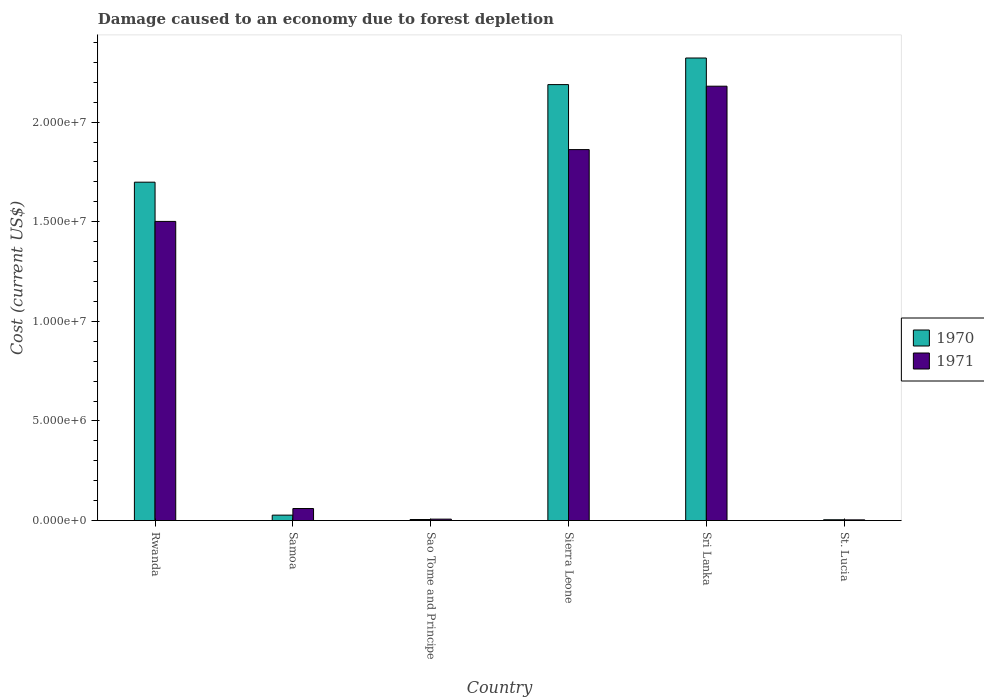How many groups of bars are there?
Ensure brevity in your answer.  6. Are the number of bars per tick equal to the number of legend labels?
Provide a short and direct response. Yes. Are the number of bars on each tick of the X-axis equal?
Your answer should be compact. Yes. How many bars are there on the 4th tick from the left?
Offer a terse response. 2. What is the label of the 2nd group of bars from the left?
Your answer should be compact. Samoa. What is the cost of damage caused due to forest depletion in 1970 in St. Lucia?
Provide a succinct answer. 4.11e+04. Across all countries, what is the maximum cost of damage caused due to forest depletion in 1971?
Provide a succinct answer. 2.18e+07. Across all countries, what is the minimum cost of damage caused due to forest depletion in 1970?
Give a very brief answer. 4.11e+04. In which country was the cost of damage caused due to forest depletion in 1970 maximum?
Offer a terse response. Sri Lanka. In which country was the cost of damage caused due to forest depletion in 1971 minimum?
Provide a short and direct response. St. Lucia. What is the total cost of damage caused due to forest depletion in 1970 in the graph?
Provide a short and direct response. 6.24e+07. What is the difference between the cost of damage caused due to forest depletion in 1970 in Samoa and that in St. Lucia?
Keep it short and to the point. 2.32e+05. What is the difference between the cost of damage caused due to forest depletion in 1970 in Sri Lanka and the cost of damage caused due to forest depletion in 1971 in St. Lucia?
Your response must be concise. 2.32e+07. What is the average cost of damage caused due to forest depletion in 1971 per country?
Give a very brief answer. 9.36e+06. What is the difference between the cost of damage caused due to forest depletion of/in 1971 and cost of damage caused due to forest depletion of/in 1970 in Sri Lanka?
Your answer should be compact. -1.42e+06. What is the ratio of the cost of damage caused due to forest depletion in 1970 in Sao Tome and Principe to that in St. Lucia?
Provide a succinct answer. 1.29. Is the difference between the cost of damage caused due to forest depletion in 1971 in Rwanda and Samoa greater than the difference between the cost of damage caused due to forest depletion in 1970 in Rwanda and Samoa?
Provide a short and direct response. No. What is the difference between the highest and the second highest cost of damage caused due to forest depletion in 1971?
Provide a short and direct response. -6.79e+06. What is the difference between the highest and the lowest cost of damage caused due to forest depletion in 1970?
Provide a short and direct response. 2.32e+07. In how many countries, is the cost of damage caused due to forest depletion in 1971 greater than the average cost of damage caused due to forest depletion in 1971 taken over all countries?
Your response must be concise. 3. What does the 1st bar from the left in Rwanda represents?
Provide a short and direct response. 1970. What does the 2nd bar from the right in Sri Lanka represents?
Offer a very short reply. 1970. How many bars are there?
Offer a terse response. 12. What is the difference between two consecutive major ticks on the Y-axis?
Provide a succinct answer. 5.00e+06. Are the values on the major ticks of Y-axis written in scientific E-notation?
Offer a very short reply. Yes. Does the graph contain any zero values?
Keep it short and to the point. No. Does the graph contain grids?
Make the answer very short. No. Where does the legend appear in the graph?
Keep it short and to the point. Center right. How many legend labels are there?
Your response must be concise. 2. What is the title of the graph?
Provide a succinct answer. Damage caused to an economy due to forest depletion. Does "2000" appear as one of the legend labels in the graph?
Provide a succinct answer. No. What is the label or title of the X-axis?
Your answer should be compact. Country. What is the label or title of the Y-axis?
Provide a succinct answer. Cost (current US$). What is the Cost (current US$) of 1970 in Rwanda?
Offer a terse response. 1.70e+07. What is the Cost (current US$) of 1971 in Rwanda?
Keep it short and to the point. 1.50e+07. What is the Cost (current US$) of 1970 in Samoa?
Give a very brief answer. 2.73e+05. What is the Cost (current US$) of 1971 in Samoa?
Provide a short and direct response. 6.05e+05. What is the Cost (current US$) of 1970 in Sao Tome and Principe?
Your answer should be compact. 5.31e+04. What is the Cost (current US$) in 1971 in Sao Tome and Principe?
Ensure brevity in your answer.  7.23e+04. What is the Cost (current US$) of 1970 in Sierra Leone?
Offer a terse response. 2.19e+07. What is the Cost (current US$) of 1971 in Sierra Leone?
Your response must be concise. 1.86e+07. What is the Cost (current US$) of 1970 in Sri Lanka?
Make the answer very short. 2.32e+07. What is the Cost (current US$) of 1971 in Sri Lanka?
Keep it short and to the point. 2.18e+07. What is the Cost (current US$) in 1970 in St. Lucia?
Your answer should be very brief. 4.11e+04. What is the Cost (current US$) in 1971 in St. Lucia?
Your response must be concise. 3.58e+04. Across all countries, what is the maximum Cost (current US$) in 1970?
Provide a short and direct response. 2.32e+07. Across all countries, what is the maximum Cost (current US$) of 1971?
Ensure brevity in your answer.  2.18e+07. Across all countries, what is the minimum Cost (current US$) of 1970?
Give a very brief answer. 4.11e+04. Across all countries, what is the minimum Cost (current US$) in 1971?
Your answer should be very brief. 3.58e+04. What is the total Cost (current US$) of 1970 in the graph?
Keep it short and to the point. 6.24e+07. What is the total Cost (current US$) of 1971 in the graph?
Provide a succinct answer. 5.61e+07. What is the difference between the Cost (current US$) of 1970 in Rwanda and that in Samoa?
Offer a very short reply. 1.67e+07. What is the difference between the Cost (current US$) in 1971 in Rwanda and that in Samoa?
Your answer should be compact. 1.44e+07. What is the difference between the Cost (current US$) in 1970 in Rwanda and that in Sao Tome and Principe?
Give a very brief answer. 1.69e+07. What is the difference between the Cost (current US$) in 1971 in Rwanda and that in Sao Tome and Principe?
Your answer should be very brief. 1.49e+07. What is the difference between the Cost (current US$) in 1970 in Rwanda and that in Sierra Leone?
Provide a succinct answer. -4.90e+06. What is the difference between the Cost (current US$) in 1971 in Rwanda and that in Sierra Leone?
Provide a short and direct response. -3.60e+06. What is the difference between the Cost (current US$) in 1970 in Rwanda and that in Sri Lanka?
Ensure brevity in your answer.  -6.23e+06. What is the difference between the Cost (current US$) of 1971 in Rwanda and that in Sri Lanka?
Offer a very short reply. -6.79e+06. What is the difference between the Cost (current US$) of 1970 in Rwanda and that in St. Lucia?
Keep it short and to the point. 1.69e+07. What is the difference between the Cost (current US$) of 1971 in Rwanda and that in St. Lucia?
Provide a short and direct response. 1.50e+07. What is the difference between the Cost (current US$) of 1970 in Samoa and that in Sao Tome and Principe?
Ensure brevity in your answer.  2.20e+05. What is the difference between the Cost (current US$) in 1971 in Samoa and that in Sao Tome and Principe?
Your response must be concise. 5.33e+05. What is the difference between the Cost (current US$) of 1970 in Samoa and that in Sierra Leone?
Your response must be concise. -2.16e+07. What is the difference between the Cost (current US$) of 1971 in Samoa and that in Sierra Leone?
Provide a succinct answer. -1.80e+07. What is the difference between the Cost (current US$) of 1970 in Samoa and that in Sri Lanka?
Your answer should be compact. -2.29e+07. What is the difference between the Cost (current US$) of 1971 in Samoa and that in Sri Lanka?
Your response must be concise. -2.12e+07. What is the difference between the Cost (current US$) in 1970 in Samoa and that in St. Lucia?
Provide a short and direct response. 2.32e+05. What is the difference between the Cost (current US$) of 1971 in Samoa and that in St. Lucia?
Provide a succinct answer. 5.69e+05. What is the difference between the Cost (current US$) of 1970 in Sao Tome and Principe and that in Sierra Leone?
Your answer should be compact. -2.18e+07. What is the difference between the Cost (current US$) of 1971 in Sao Tome and Principe and that in Sierra Leone?
Offer a very short reply. -1.85e+07. What is the difference between the Cost (current US$) in 1970 in Sao Tome and Principe and that in Sri Lanka?
Your answer should be compact. -2.32e+07. What is the difference between the Cost (current US$) in 1971 in Sao Tome and Principe and that in Sri Lanka?
Give a very brief answer. -2.17e+07. What is the difference between the Cost (current US$) in 1970 in Sao Tome and Principe and that in St. Lucia?
Make the answer very short. 1.20e+04. What is the difference between the Cost (current US$) of 1971 in Sao Tome and Principe and that in St. Lucia?
Your answer should be very brief. 3.65e+04. What is the difference between the Cost (current US$) of 1970 in Sierra Leone and that in Sri Lanka?
Provide a short and direct response. -1.34e+06. What is the difference between the Cost (current US$) of 1971 in Sierra Leone and that in Sri Lanka?
Ensure brevity in your answer.  -3.18e+06. What is the difference between the Cost (current US$) of 1970 in Sierra Leone and that in St. Lucia?
Provide a succinct answer. 2.18e+07. What is the difference between the Cost (current US$) in 1971 in Sierra Leone and that in St. Lucia?
Ensure brevity in your answer.  1.86e+07. What is the difference between the Cost (current US$) in 1970 in Sri Lanka and that in St. Lucia?
Offer a very short reply. 2.32e+07. What is the difference between the Cost (current US$) of 1971 in Sri Lanka and that in St. Lucia?
Provide a succinct answer. 2.18e+07. What is the difference between the Cost (current US$) of 1970 in Rwanda and the Cost (current US$) of 1971 in Samoa?
Your answer should be very brief. 1.64e+07. What is the difference between the Cost (current US$) in 1970 in Rwanda and the Cost (current US$) in 1971 in Sao Tome and Principe?
Provide a short and direct response. 1.69e+07. What is the difference between the Cost (current US$) of 1970 in Rwanda and the Cost (current US$) of 1971 in Sierra Leone?
Make the answer very short. -1.63e+06. What is the difference between the Cost (current US$) of 1970 in Rwanda and the Cost (current US$) of 1971 in Sri Lanka?
Your answer should be very brief. -4.82e+06. What is the difference between the Cost (current US$) of 1970 in Rwanda and the Cost (current US$) of 1971 in St. Lucia?
Your answer should be compact. 1.69e+07. What is the difference between the Cost (current US$) in 1970 in Samoa and the Cost (current US$) in 1971 in Sao Tome and Principe?
Provide a short and direct response. 2.01e+05. What is the difference between the Cost (current US$) in 1970 in Samoa and the Cost (current US$) in 1971 in Sierra Leone?
Give a very brief answer. -1.83e+07. What is the difference between the Cost (current US$) in 1970 in Samoa and the Cost (current US$) in 1971 in Sri Lanka?
Keep it short and to the point. -2.15e+07. What is the difference between the Cost (current US$) in 1970 in Samoa and the Cost (current US$) in 1971 in St. Lucia?
Provide a succinct answer. 2.37e+05. What is the difference between the Cost (current US$) of 1970 in Sao Tome and Principe and the Cost (current US$) of 1971 in Sierra Leone?
Your answer should be compact. -1.86e+07. What is the difference between the Cost (current US$) in 1970 in Sao Tome and Principe and the Cost (current US$) in 1971 in Sri Lanka?
Provide a short and direct response. -2.17e+07. What is the difference between the Cost (current US$) of 1970 in Sao Tome and Principe and the Cost (current US$) of 1971 in St. Lucia?
Offer a terse response. 1.73e+04. What is the difference between the Cost (current US$) of 1970 in Sierra Leone and the Cost (current US$) of 1971 in Sri Lanka?
Your answer should be compact. 8.01e+04. What is the difference between the Cost (current US$) in 1970 in Sierra Leone and the Cost (current US$) in 1971 in St. Lucia?
Offer a terse response. 2.18e+07. What is the difference between the Cost (current US$) in 1970 in Sri Lanka and the Cost (current US$) in 1971 in St. Lucia?
Your response must be concise. 2.32e+07. What is the average Cost (current US$) of 1970 per country?
Ensure brevity in your answer.  1.04e+07. What is the average Cost (current US$) of 1971 per country?
Ensure brevity in your answer.  9.36e+06. What is the difference between the Cost (current US$) of 1970 and Cost (current US$) of 1971 in Rwanda?
Offer a very short reply. 1.97e+06. What is the difference between the Cost (current US$) of 1970 and Cost (current US$) of 1971 in Samoa?
Make the answer very short. -3.32e+05. What is the difference between the Cost (current US$) of 1970 and Cost (current US$) of 1971 in Sao Tome and Principe?
Provide a short and direct response. -1.92e+04. What is the difference between the Cost (current US$) in 1970 and Cost (current US$) in 1971 in Sierra Leone?
Offer a very short reply. 3.26e+06. What is the difference between the Cost (current US$) of 1970 and Cost (current US$) of 1971 in Sri Lanka?
Offer a very short reply. 1.42e+06. What is the difference between the Cost (current US$) of 1970 and Cost (current US$) of 1971 in St. Lucia?
Your answer should be compact. 5318.94. What is the ratio of the Cost (current US$) of 1970 in Rwanda to that in Samoa?
Offer a terse response. 62.21. What is the ratio of the Cost (current US$) in 1971 in Rwanda to that in Samoa?
Your answer should be compact. 24.81. What is the ratio of the Cost (current US$) in 1970 in Rwanda to that in Sao Tome and Principe?
Keep it short and to the point. 320.03. What is the ratio of the Cost (current US$) in 1971 in Rwanda to that in Sao Tome and Principe?
Your response must be concise. 207.63. What is the ratio of the Cost (current US$) of 1970 in Rwanda to that in Sierra Leone?
Provide a succinct answer. 0.78. What is the ratio of the Cost (current US$) in 1971 in Rwanda to that in Sierra Leone?
Provide a succinct answer. 0.81. What is the ratio of the Cost (current US$) in 1970 in Rwanda to that in Sri Lanka?
Ensure brevity in your answer.  0.73. What is the ratio of the Cost (current US$) in 1971 in Rwanda to that in Sri Lanka?
Provide a succinct answer. 0.69. What is the ratio of the Cost (current US$) of 1970 in Rwanda to that in St. Lucia?
Your answer should be very brief. 413.15. What is the ratio of the Cost (current US$) of 1971 in Rwanda to that in St. Lucia?
Ensure brevity in your answer.  419.52. What is the ratio of the Cost (current US$) of 1970 in Samoa to that in Sao Tome and Principe?
Keep it short and to the point. 5.14. What is the ratio of the Cost (current US$) of 1971 in Samoa to that in Sao Tome and Principe?
Make the answer very short. 8.37. What is the ratio of the Cost (current US$) of 1970 in Samoa to that in Sierra Leone?
Provide a succinct answer. 0.01. What is the ratio of the Cost (current US$) in 1971 in Samoa to that in Sierra Leone?
Make the answer very short. 0.03. What is the ratio of the Cost (current US$) in 1970 in Samoa to that in Sri Lanka?
Offer a terse response. 0.01. What is the ratio of the Cost (current US$) of 1971 in Samoa to that in Sri Lanka?
Make the answer very short. 0.03. What is the ratio of the Cost (current US$) of 1970 in Samoa to that in St. Lucia?
Your answer should be very brief. 6.64. What is the ratio of the Cost (current US$) of 1971 in Samoa to that in St. Lucia?
Offer a terse response. 16.91. What is the ratio of the Cost (current US$) of 1970 in Sao Tome and Principe to that in Sierra Leone?
Your answer should be compact. 0. What is the ratio of the Cost (current US$) in 1971 in Sao Tome and Principe to that in Sierra Leone?
Your answer should be very brief. 0. What is the ratio of the Cost (current US$) in 1970 in Sao Tome and Principe to that in Sri Lanka?
Your response must be concise. 0. What is the ratio of the Cost (current US$) of 1971 in Sao Tome and Principe to that in Sri Lanka?
Give a very brief answer. 0. What is the ratio of the Cost (current US$) of 1970 in Sao Tome and Principe to that in St. Lucia?
Provide a short and direct response. 1.29. What is the ratio of the Cost (current US$) in 1971 in Sao Tome and Principe to that in St. Lucia?
Provide a short and direct response. 2.02. What is the ratio of the Cost (current US$) of 1970 in Sierra Leone to that in Sri Lanka?
Provide a short and direct response. 0.94. What is the ratio of the Cost (current US$) of 1971 in Sierra Leone to that in Sri Lanka?
Your answer should be very brief. 0.85. What is the ratio of the Cost (current US$) in 1970 in Sierra Leone to that in St. Lucia?
Your response must be concise. 532.27. What is the ratio of the Cost (current US$) in 1971 in Sierra Leone to that in St. Lucia?
Keep it short and to the point. 520.23. What is the ratio of the Cost (current US$) of 1970 in Sri Lanka to that in St. Lucia?
Offer a terse response. 564.74. What is the ratio of the Cost (current US$) of 1971 in Sri Lanka to that in St. Lucia?
Provide a short and direct response. 609.13. What is the difference between the highest and the second highest Cost (current US$) in 1970?
Your answer should be compact. 1.34e+06. What is the difference between the highest and the second highest Cost (current US$) in 1971?
Provide a succinct answer. 3.18e+06. What is the difference between the highest and the lowest Cost (current US$) in 1970?
Make the answer very short. 2.32e+07. What is the difference between the highest and the lowest Cost (current US$) in 1971?
Provide a short and direct response. 2.18e+07. 